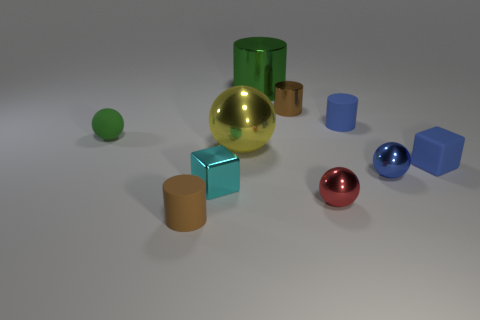Subtract all yellow blocks. Subtract all cyan cylinders. How many blocks are left? 2 Subtract all purple cylinders. How many red balls are left? 1 Add 5 things. How many cyans exist? 0 Subtract all small brown cylinders. Subtract all big objects. How many objects are left? 6 Add 4 big yellow metal things. How many big yellow metal things are left? 5 Add 4 large gray things. How many large gray things exist? 4 Subtract all cyan cubes. How many cubes are left? 1 Subtract all tiny blue metal spheres. How many spheres are left? 3 Subtract 1 cyan cubes. How many objects are left? 9 Subtract all brown cylinders. How many were subtracted if there are1brown cylinders left? 1 